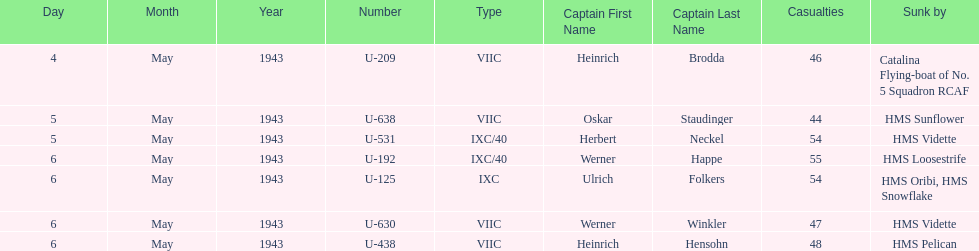How many more casualties occurred on may 6 compared to may 4? 158. 